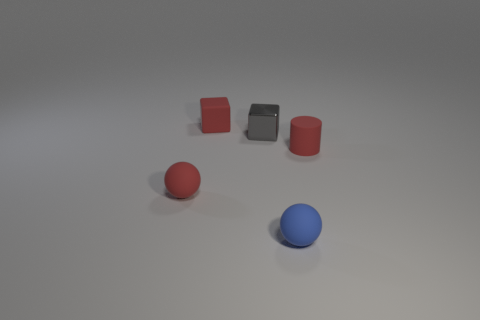What number of purple objects are small things or rubber balls?
Ensure brevity in your answer.  0. Are there the same number of tiny metal blocks behind the red block and blue spheres that are to the right of the small blue sphere?
Keep it short and to the point. Yes. Do the matte thing right of the blue thing and the thing that is to the left of the red rubber cube have the same shape?
Ensure brevity in your answer.  No. Is there any other thing that is the same shape as the tiny shiny object?
Give a very brief answer. Yes. There is a blue object that is made of the same material as the tiny red ball; what is its shape?
Your response must be concise. Sphere. Are there an equal number of red rubber cylinders that are in front of the tiny metal block and blocks?
Provide a succinct answer. No. Is the material of the red thing that is right of the shiny block the same as the ball right of the small red sphere?
Make the answer very short. Yes. What shape is the red rubber object on the right side of the tiny red matte thing that is behind the tiny shiny block?
Offer a very short reply. Cylinder. The small cylinder that is the same material as the red block is what color?
Give a very brief answer. Red. Do the cylinder and the matte block have the same color?
Ensure brevity in your answer.  Yes. 